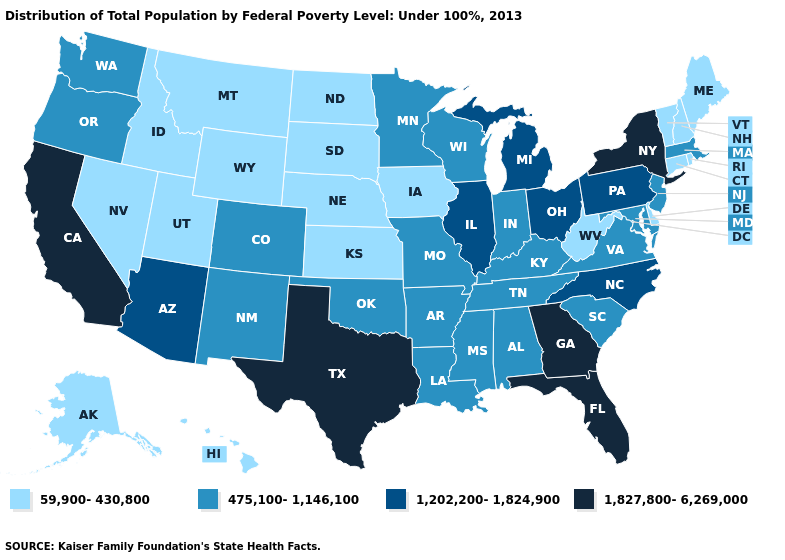Among the states that border Pennsylvania , does Maryland have the lowest value?
Short answer required. No. What is the value of Arkansas?
Answer briefly. 475,100-1,146,100. Among the states that border Arkansas , which have the highest value?
Quick response, please. Texas. What is the value of Virginia?
Write a very short answer. 475,100-1,146,100. Does the map have missing data?
Write a very short answer. No. Among the states that border South Carolina , which have the lowest value?
Keep it brief. North Carolina. Name the states that have a value in the range 1,827,800-6,269,000?
Short answer required. California, Florida, Georgia, New York, Texas. Name the states that have a value in the range 59,900-430,800?
Give a very brief answer. Alaska, Connecticut, Delaware, Hawaii, Idaho, Iowa, Kansas, Maine, Montana, Nebraska, Nevada, New Hampshire, North Dakota, Rhode Island, South Dakota, Utah, Vermont, West Virginia, Wyoming. What is the value of New Mexico?
Write a very short answer. 475,100-1,146,100. Does the map have missing data?
Concise answer only. No. Name the states that have a value in the range 1,202,200-1,824,900?
Give a very brief answer. Arizona, Illinois, Michigan, North Carolina, Ohio, Pennsylvania. What is the lowest value in the USA?
Answer briefly. 59,900-430,800. Among the states that border Ohio , which have the highest value?
Answer briefly. Michigan, Pennsylvania. Name the states that have a value in the range 59,900-430,800?
Answer briefly. Alaska, Connecticut, Delaware, Hawaii, Idaho, Iowa, Kansas, Maine, Montana, Nebraska, Nevada, New Hampshire, North Dakota, Rhode Island, South Dakota, Utah, Vermont, West Virginia, Wyoming. Which states have the lowest value in the USA?
Write a very short answer. Alaska, Connecticut, Delaware, Hawaii, Idaho, Iowa, Kansas, Maine, Montana, Nebraska, Nevada, New Hampshire, North Dakota, Rhode Island, South Dakota, Utah, Vermont, West Virginia, Wyoming. 